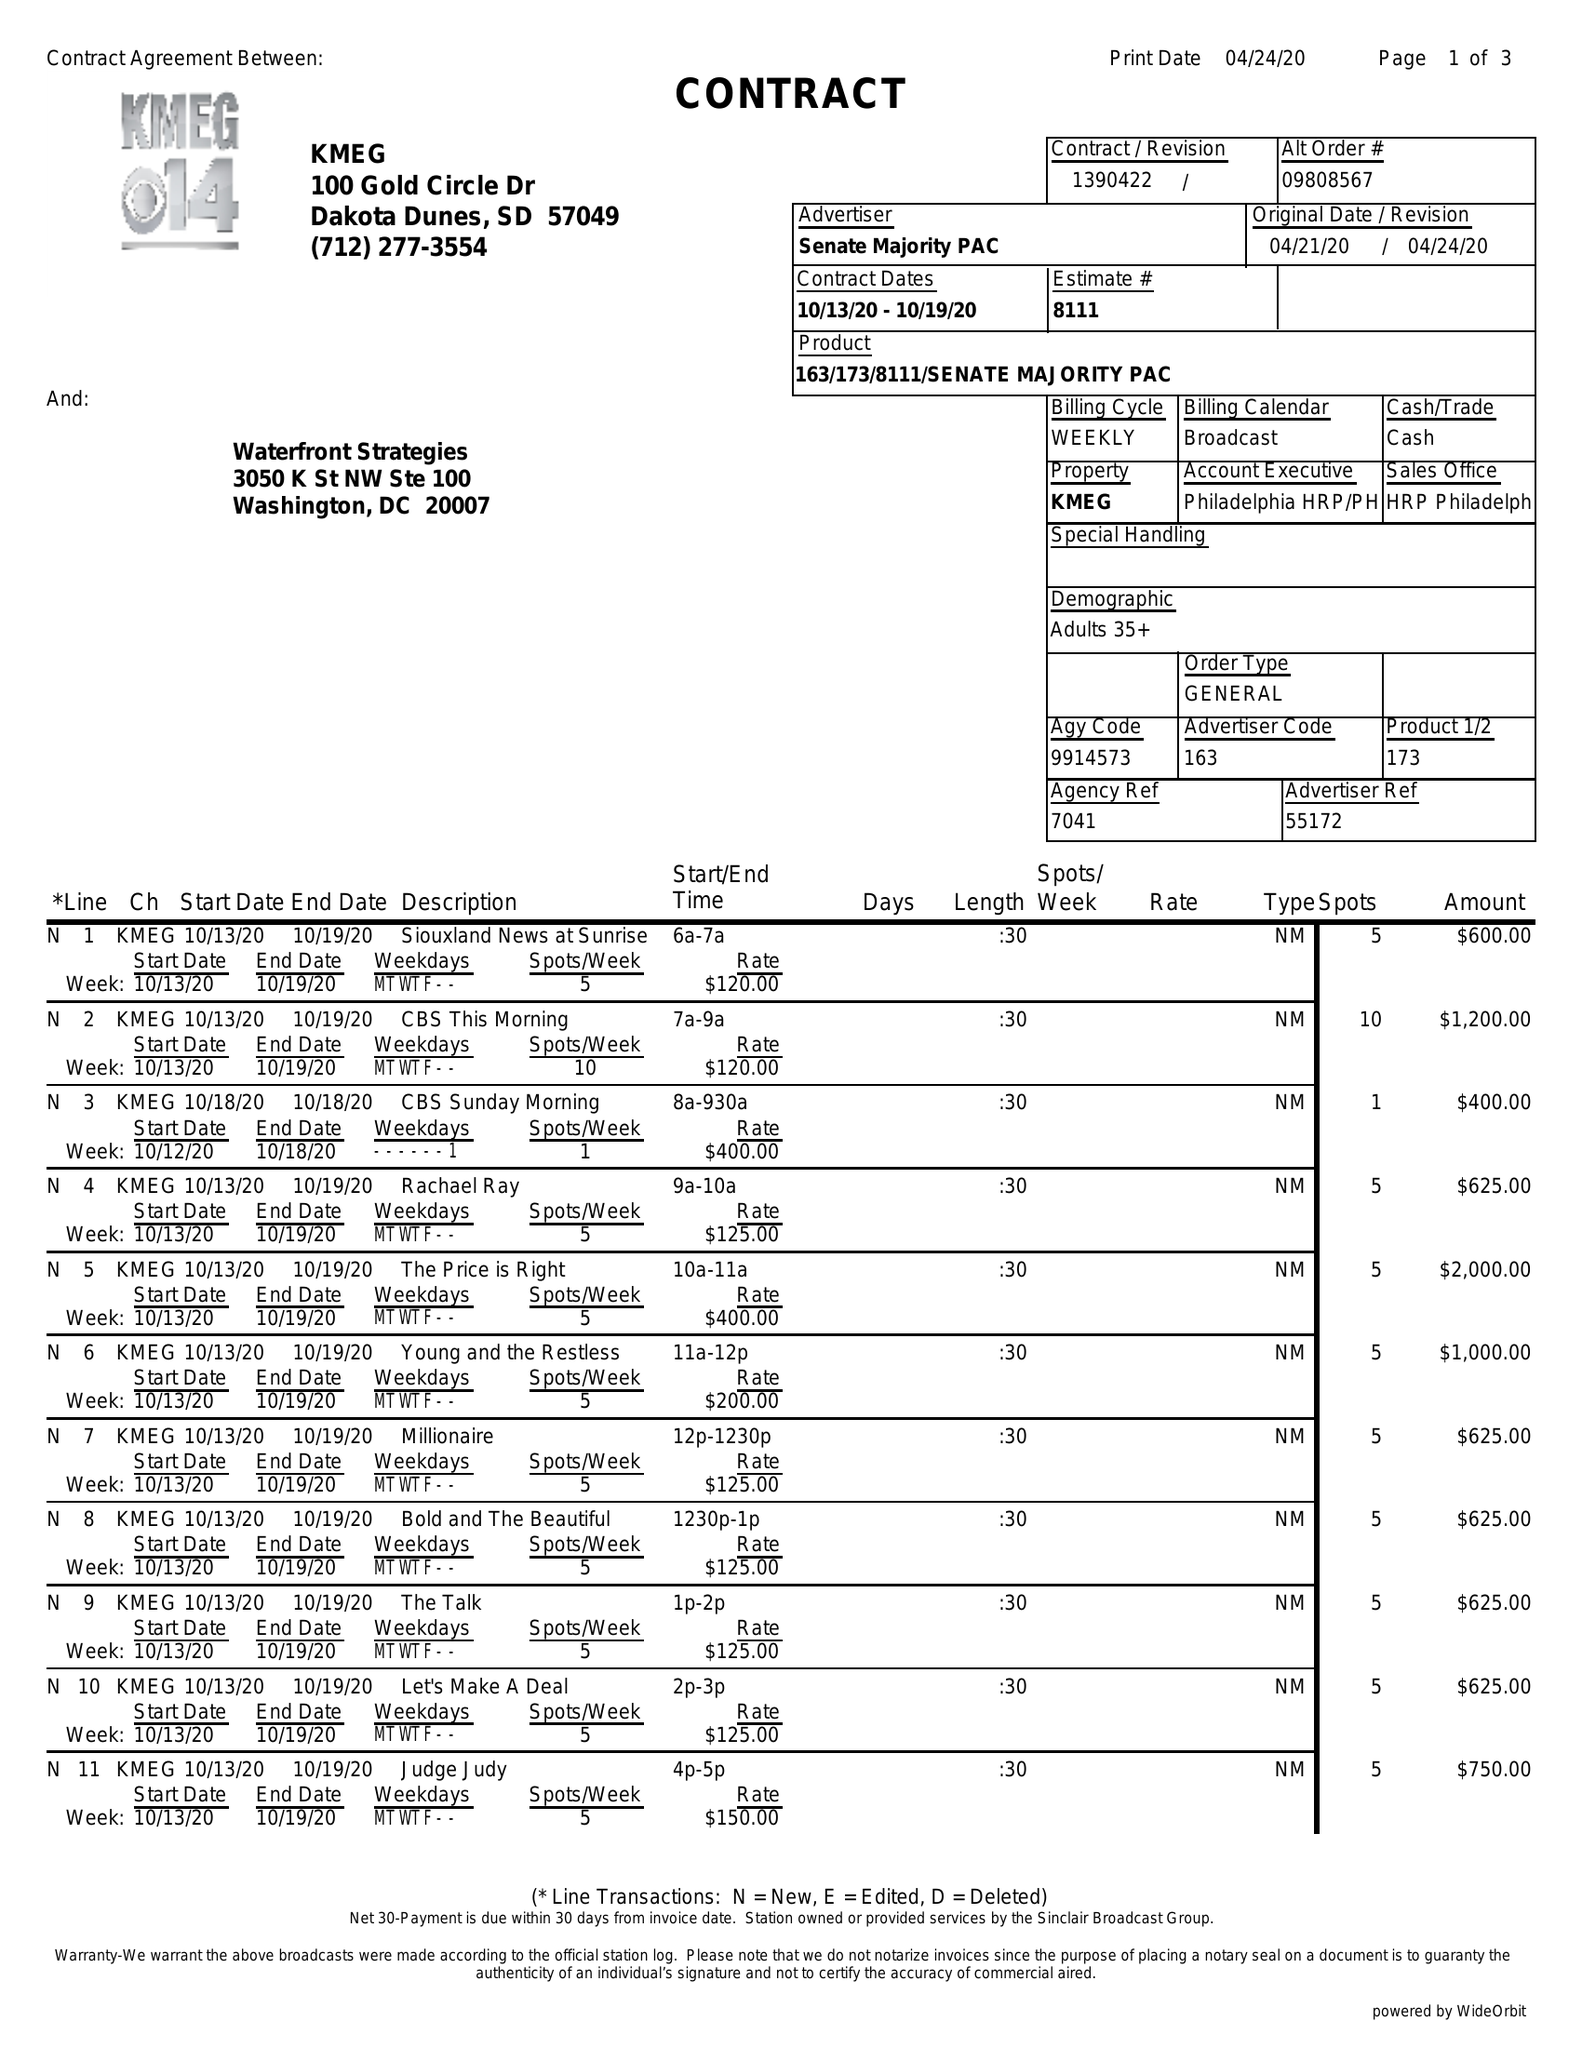What is the value for the contract_num?
Answer the question using a single word or phrase. 1390422 